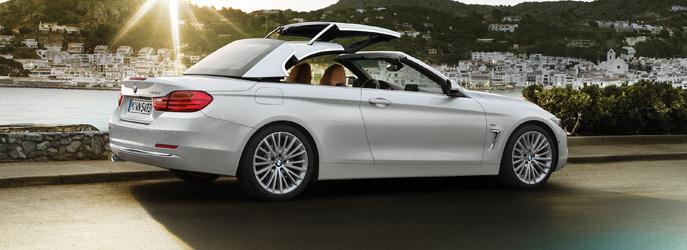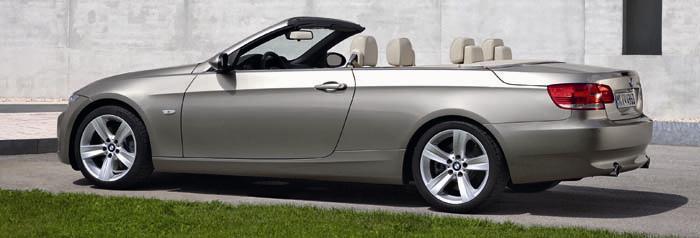The first image is the image on the left, the second image is the image on the right. For the images displayed, is the sentence "dark colored convertibles are on oposite sides" factually correct? Answer yes or no. No. The first image is the image on the left, the second image is the image on the right. Examine the images to the left and right. Is the description "In one of the images, the top of the convertible car is in the middle of coming up or down" accurate? Answer yes or no. Yes. 